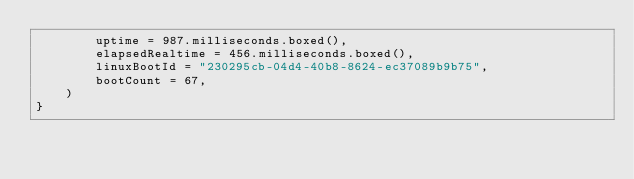<code> <loc_0><loc_0><loc_500><loc_500><_Kotlin_>        uptime = 987.milliseconds.boxed(),
        elapsedRealtime = 456.milliseconds.boxed(),
        linuxBootId = "230295cb-04d4-40b8-8624-ec37089b9b75",
        bootCount = 67,
    )
}
</code> 